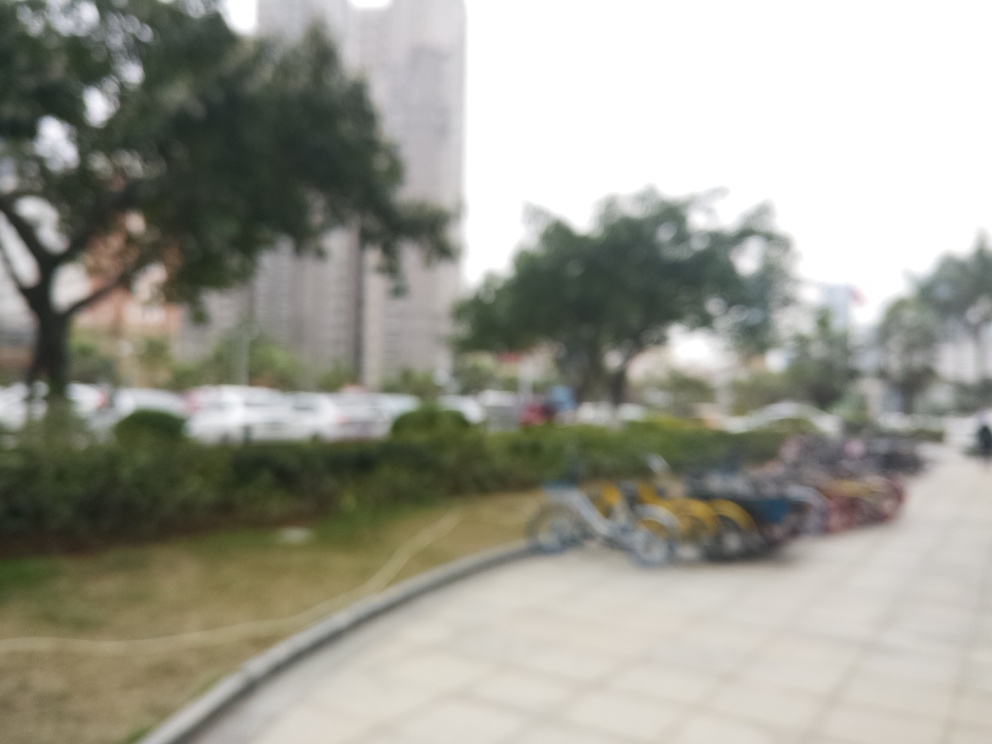What might be the reason for the blurriness of this image? The blurriness in the image could be due to several factors, such as camera movement during the exposure, incorrect focus settings, or an intentional artistic choice to create a softened or dreamlike effect. 